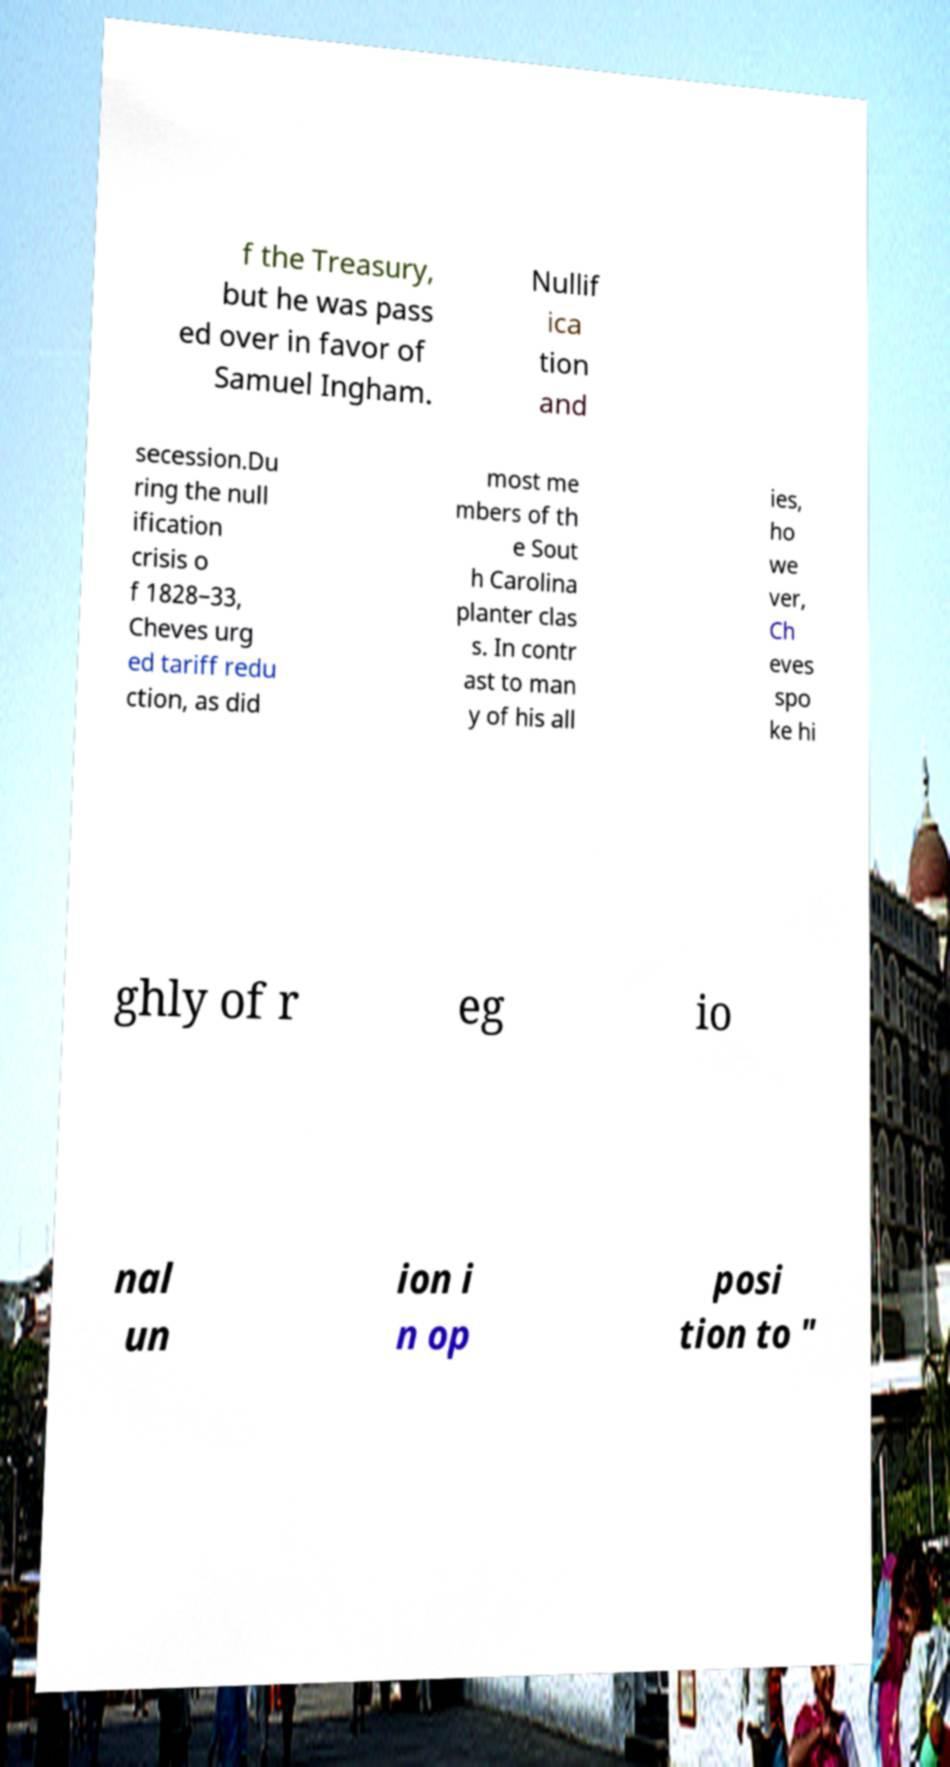Can you accurately transcribe the text from the provided image for me? f the Treasury, but he was pass ed over in favor of Samuel Ingham. Nullif ica tion and secession.Du ring the null ification crisis o f 1828–33, Cheves urg ed tariff redu ction, as did most me mbers of th e Sout h Carolina planter clas s. In contr ast to man y of his all ies, ho we ver, Ch eves spo ke hi ghly of r eg io nal un ion i n op posi tion to " 